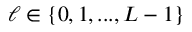<formula> <loc_0><loc_0><loc_500><loc_500>\ell \in \{ 0 , 1 , \dots , L - 1 \}</formula> 